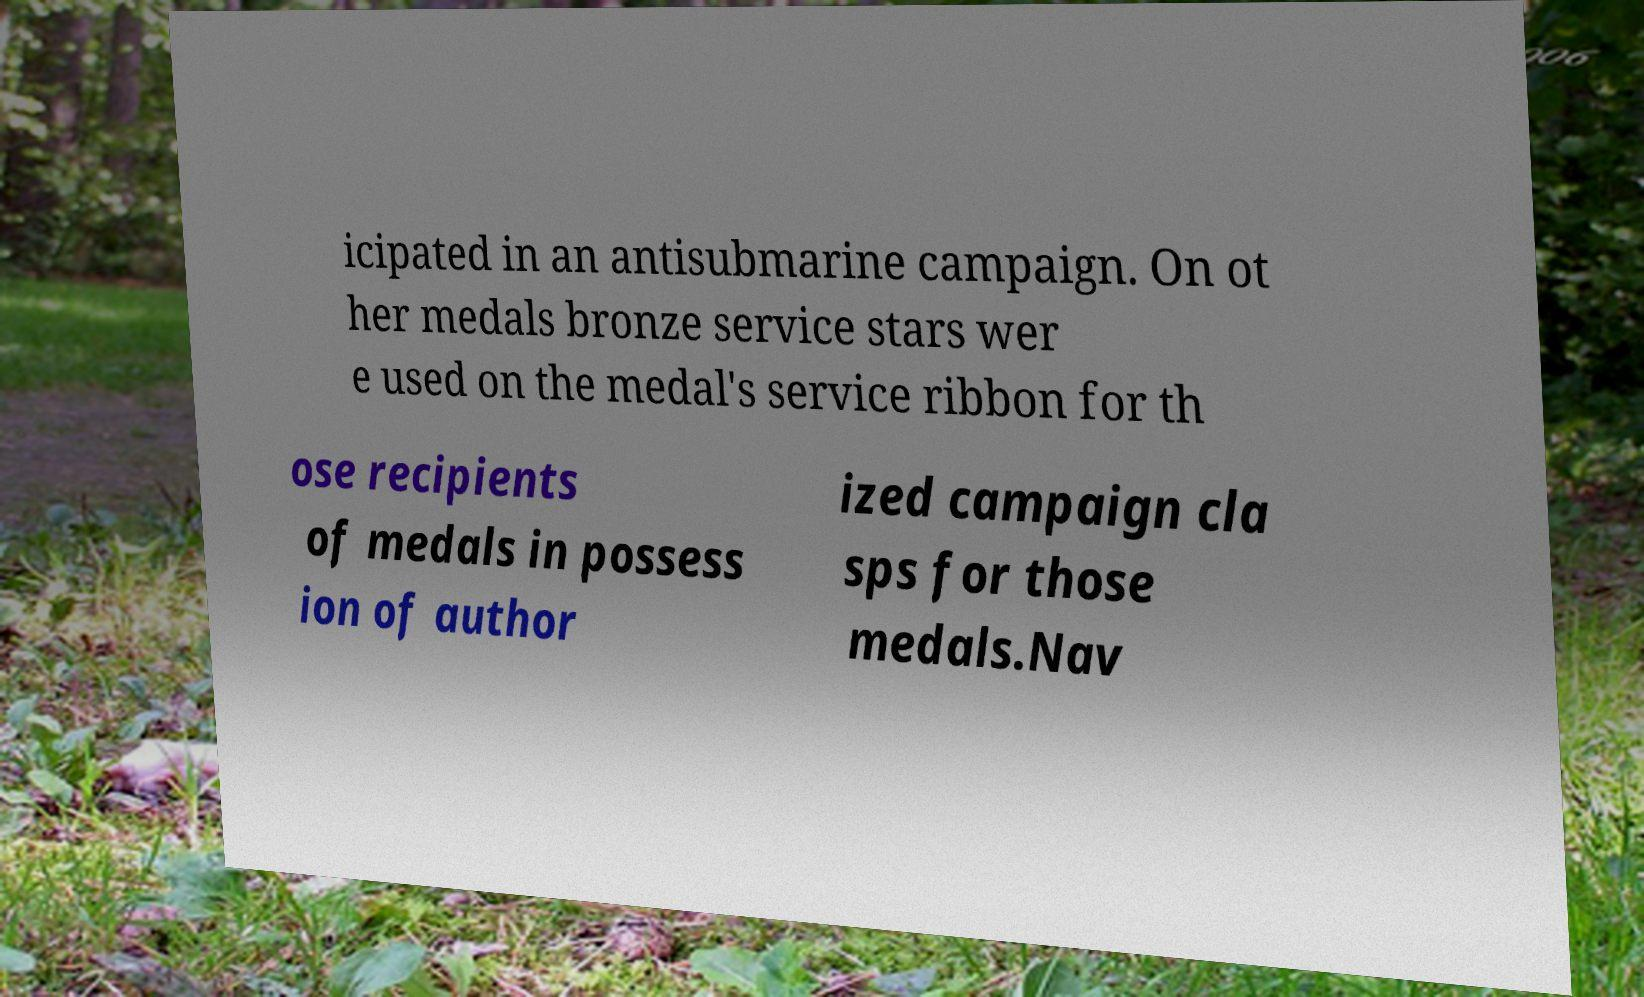Can you accurately transcribe the text from the provided image for me? icipated in an antisubmarine campaign. On ot her medals bronze service stars wer e used on the medal's service ribbon for th ose recipients of medals in possess ion of author ized campaign cla sps for those medals.Nav 